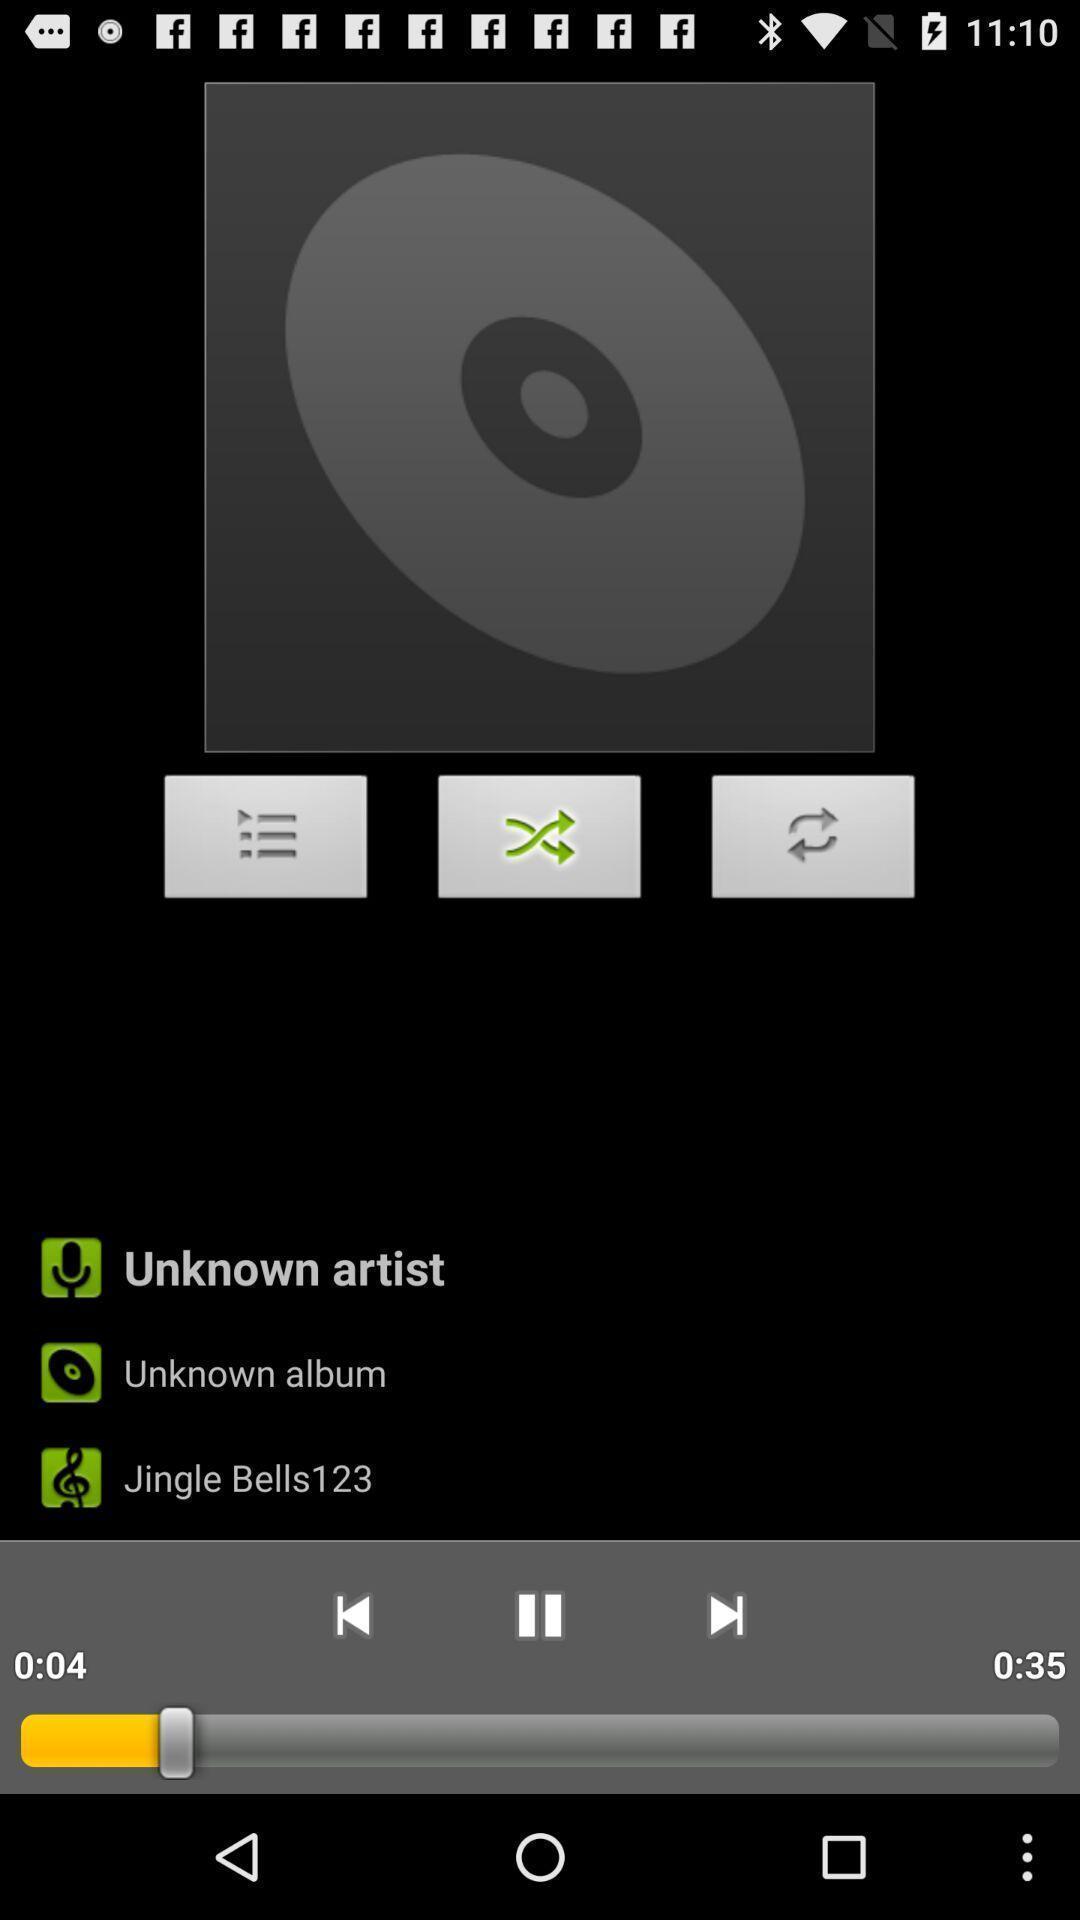What details can you identify in this image? Various options for music player app. 